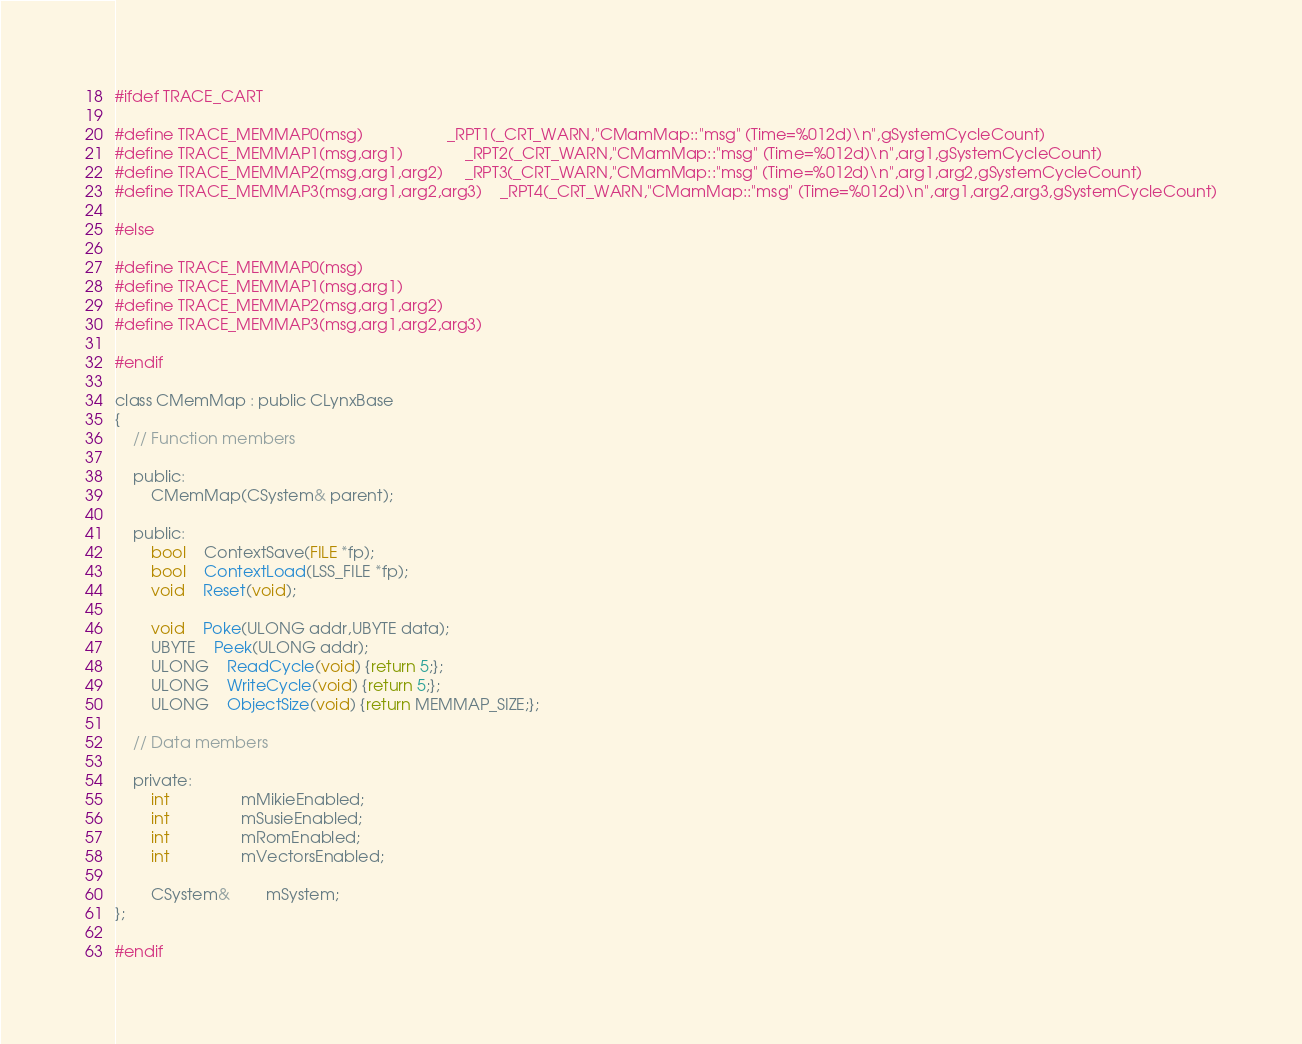Convert code to text. <code><loc_0><loc_0><loc_500><loc_500><_C_>
#ifdef TRACE_CART

#define TRACE_MEMMAP0(msg)					_RPT1(_CRT_WARN,"CMamMap::"msg" (Time=%012d)\n",gSystemCycleCount)
#define TRACE_MEMMAP1(msg,arg1)				_RPT2(_CRT_WARN,"CMamMap::"msg" (Time=%012d)\n",arg1,gSystemCycleCount)
#define TRACE_MEMMAP2(msg,arg1,arg2)		_RPT3(_CRT_WARN,"CMamMap::"msg" (Time=%012d)\n",arg1,arg2,gSystemCycleCount)
#define TRACE_MEMMAP3(msg,arg1,arg2,arg3)	_RPT4(_CRT_WARN,"CMamMap::"msg" (Time=%012d)\n",arg1,arg2,arg3,gSystemCycleCount)

#else

#define TRACE_MEMMAP0(msg)
#define TRACE_MEMMAP1(msg,arg1)
#define TRACE_MEMMAP2(msg,arg1,arg2)
#define TRACE_MEMMAP3(msg,arg1,arg2,arg3)

#endif

class CMemMap : public CLynxBase
{
	// Function members

	public:
		CMemMap(CSystem& parent);

	public:
		bool	ContextSave(FILE *fp);
		bool	ContextLoad(LSS_FILE *fp);
		void	Reset(void);

		void	Poke(ULONG addr,UBYTE data);
		UBYTE	Peek(ULONG addr);
		ULONG	ReadCycle(void) {return 5;};
		ULONG	WriteCycle(void) {return 5;};
		ULONG	ObjectSize(void) {return MEMMAP_SIZE;};

	// Data members

	private:
		int				mMikieEnabled;
		int				mSusieEnabled;
		int				mRomEnabled;
		int				mVectorsEnabled;

		CSystem&		mSystem;
};

#endif

</code> 